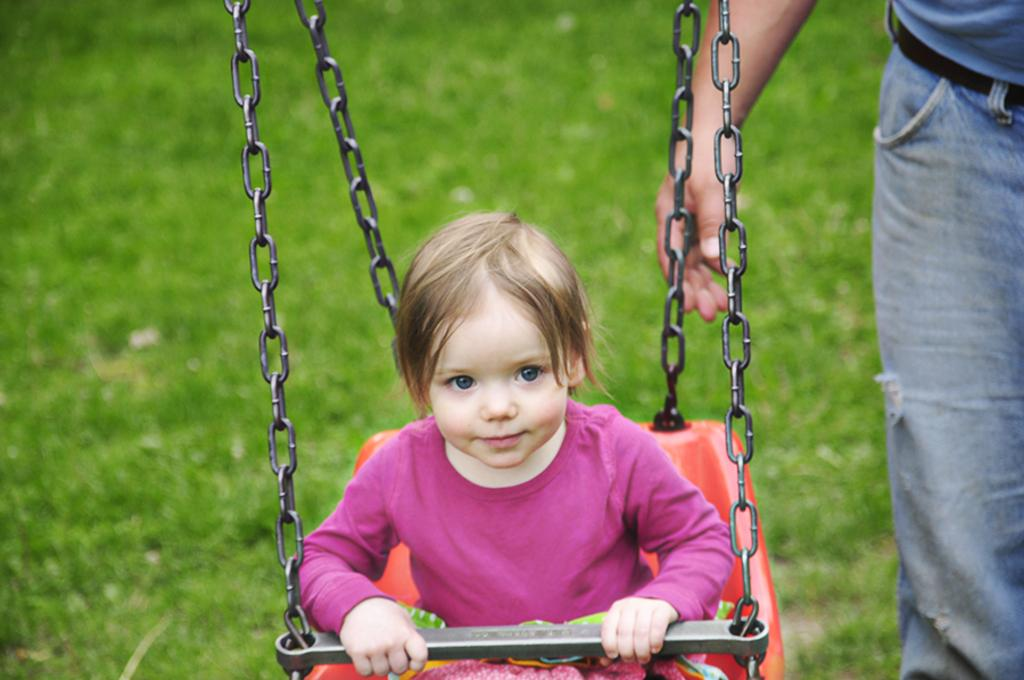What is the girl doing in the image? The small girl is sitting in a cradle. Can you describe the person standing in the image? There is a person standing at the right side. What type of surface is the girl sitting on? Green grass is visible on the ground. How many silver knees does the person standing have in the image? There is no mention of silver or knees in the image, so it is not possible to answer that question. 